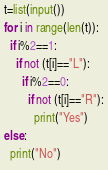<code> <loc_0><loc_0><loc_500><loc_500><_Python_>t=list(input())
for i in range(len(t)):
  if i%2==1:
    if not (t[i]=="L"):
      if i%2==0:
        if not (t[i]=="R"):
          print("Yes")
else:
  print("No")</code> 